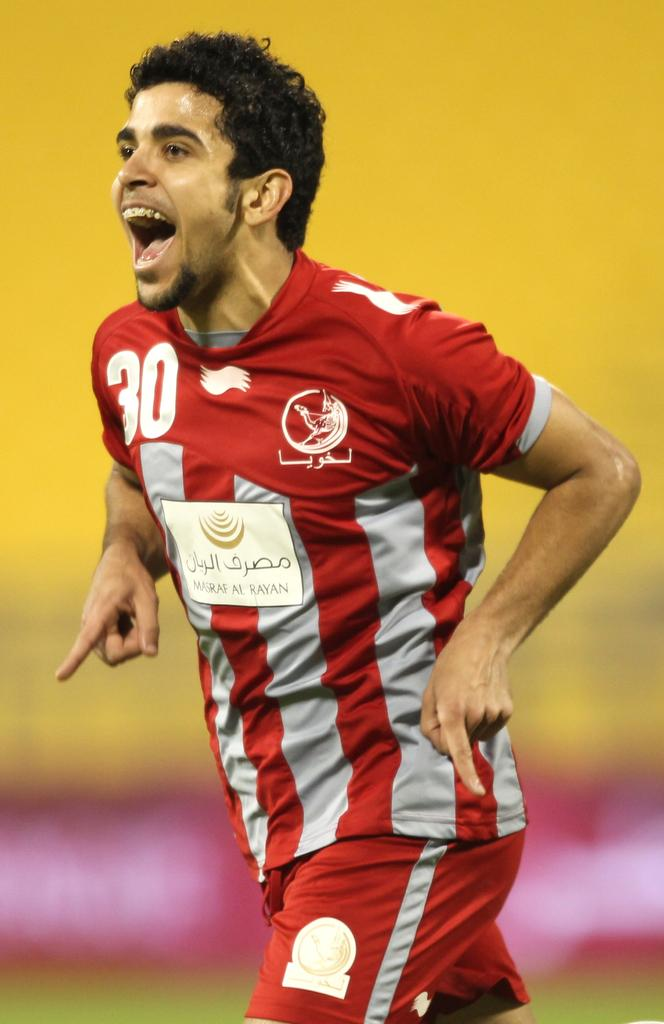Provide a one-sentence caption for the provided image. A guy with a red soccer outfit with the number 30 in white. 